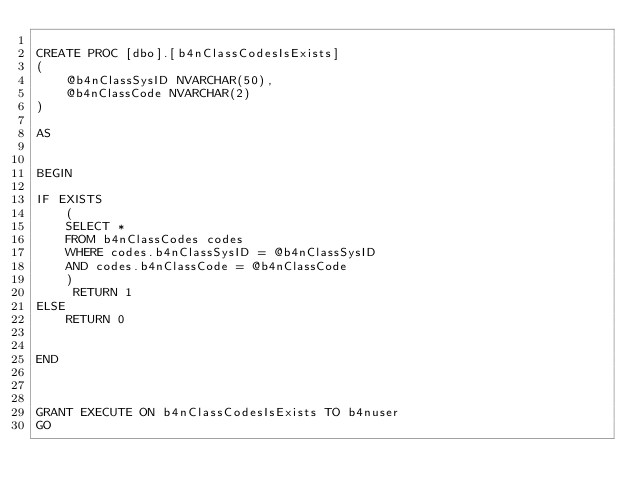<code> <loc_0><loc_0><loc_500><loc_500><_SQL_>
CREATE PROC [dbo].[b4nClassCodesIsExists]
(
	@b4nClassSysID NVARCHAR(50),
	@b4nClassCode NVARCHAR(2)
)

AS


BEGIN

IF EXISTS
	(
	SELECT * 
	FROM b4nClassCodes codes
	WHERE codes.b4nClassSysID = @b4nClassSysID
	AND codes.b4nClassCode = @b4nClassCode
	)
	 RETURN 1
ELSE
	RETURN 0	 


END



GRANT EXECUTE ON b4nClassCodesIsExists TO b4nuser
GO
</code> 